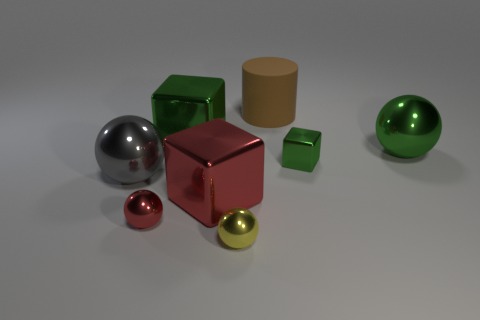Is there any other thing that is the same shape as the large matte thing? Yes, the shape of the large green cube is identical to that of the small red cube to its right; they are both cubes but differ in size and surface finish. 